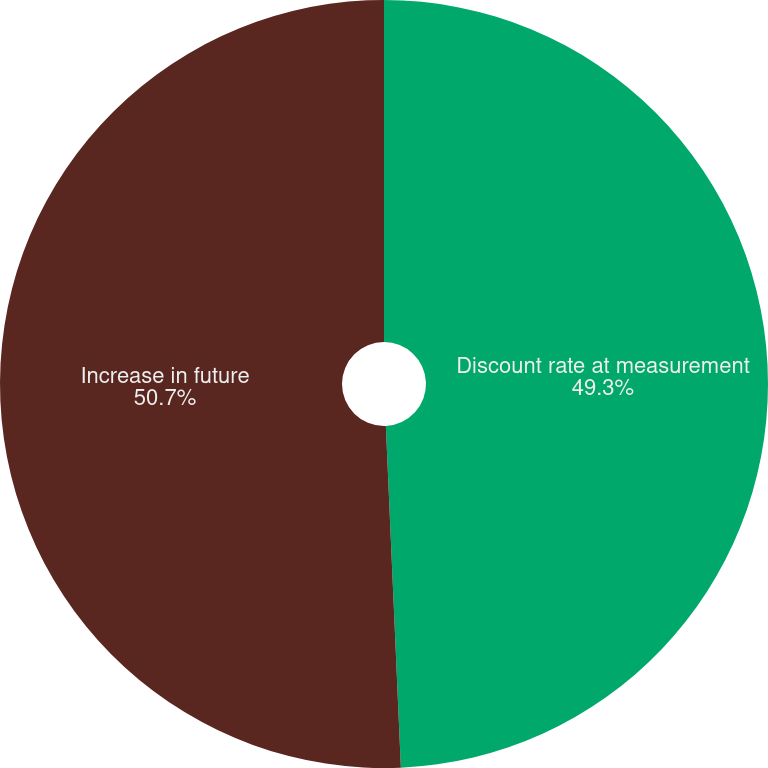Convert chart to OTSL. <chart><loc_0><loc_0><loc_500><loc_500><pie_chart><fcel>Discount rate at measurement<fcel>Increase in future<nl><fcel>49.3%<fcel>50.7%<nl></chart> 